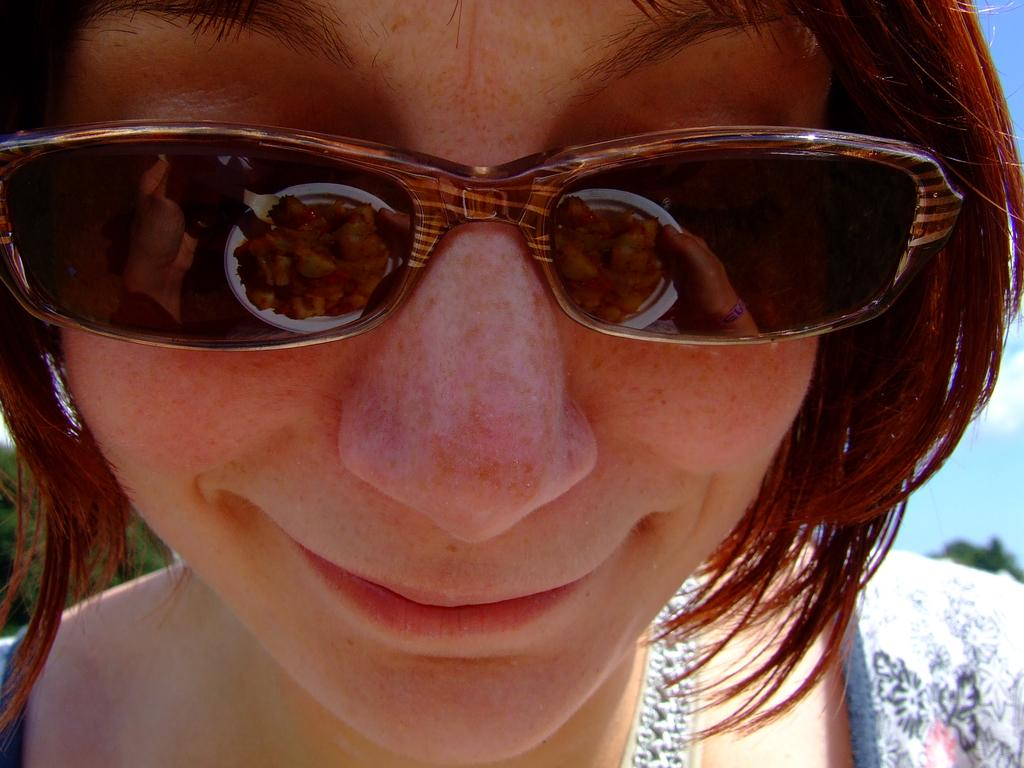What can be observed about the person in the image? There is a person with spectacles in the image, and they are smiling. What is visible on the plate in the image? There is a reflection of food and a fork on a plate in the image. What can be seen in the background of the image? There is a tree and the sky visible in the background of the image. Where is the flock of birds perched in the image? There is no flock of birds present in the image. How many drops of water are visible on the plate in the image? There is no water visible on the plate in the image; it only shows a reflection of food and a fork. 